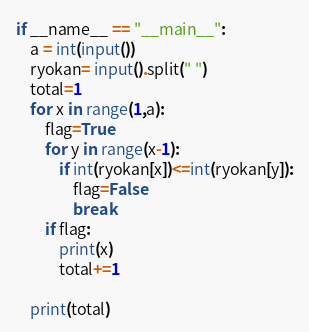<code> <loc_0><loc_0><loc_500><loc_500><_Python_>if __name__ == "__main__":
    a = int(input())
    ryokan= input().split(" ")
    total=1
    for x in range(1,a):
        flag=True
        for y in range(x-1):
            if int(ryokan[x])<=int(ryokan[y]):
                flag=False
                break
        if flag:
            print(x)        
            total+=1
                
    print(total)</code> 